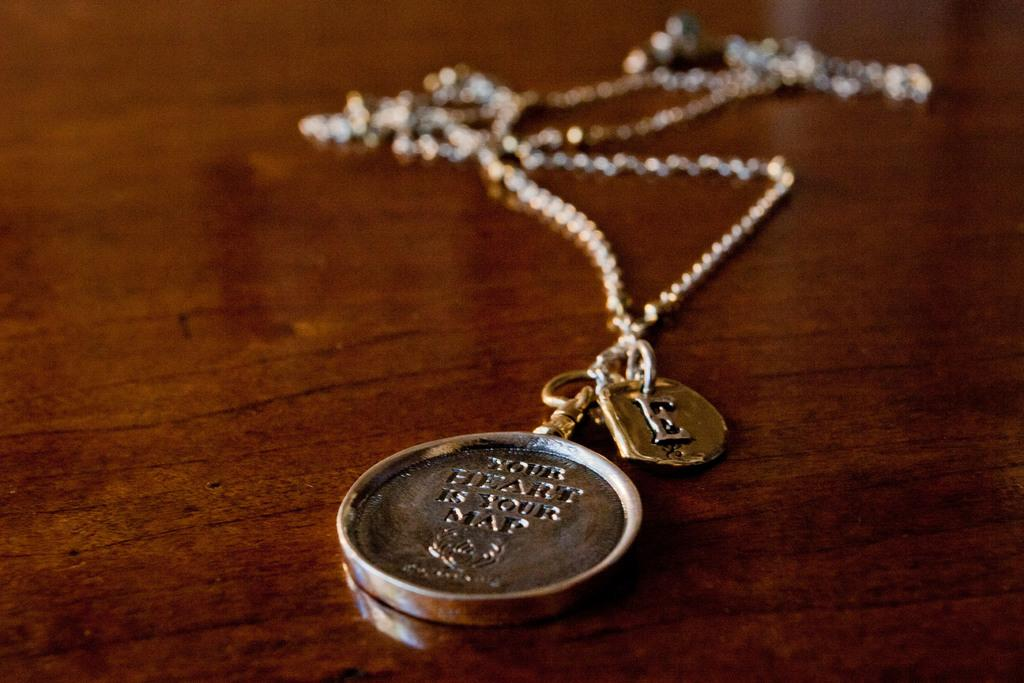<image>
Summarize the visual content of the image. a necklace with a coin on the end of it that says 'your heart is your map' 